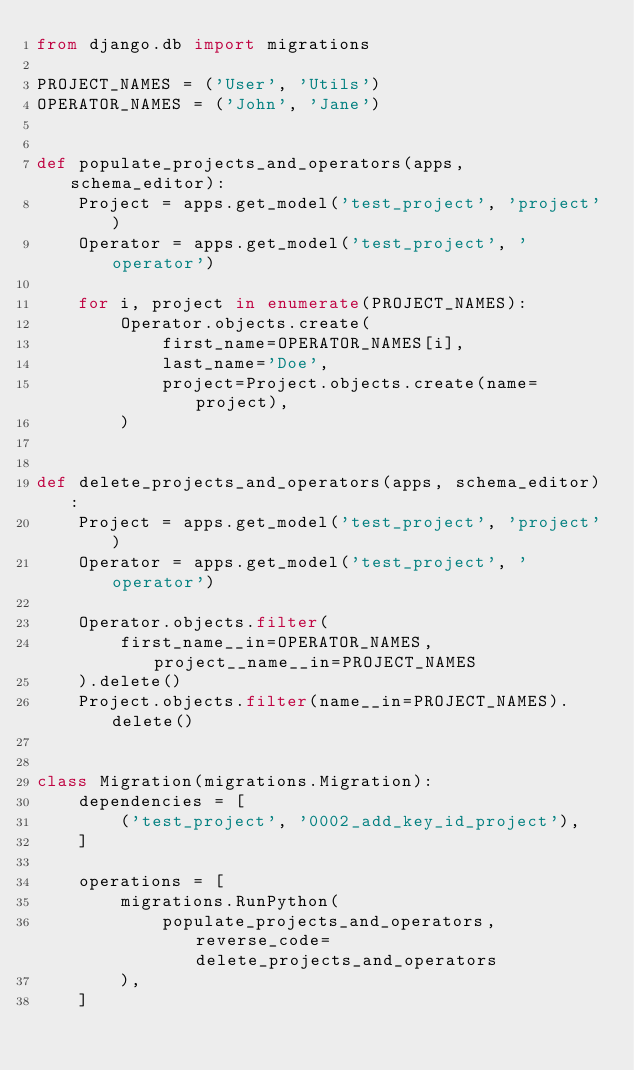Convert code to text. <code><loc_0><loc_0><loc_500><loc_500><_Python_>from django.db import migrations

PROJECT_NAMES = ('User', 'Utils')
OPERATOR_NAMES = ('John', 'Jane')


def populate_projects_and_operators(apps, schema_editor):
    Project = apps.get_model('test_project', 'project')
    Operator = apps.get_model('test_project', 'operator')

    for i, project in enumerate(PROJECT_NAMES):
        Operator.objects.create(
            first_name=OPERATOR_NAMES[i],
            last_name='Doe',
            project=Project.objects.create(name=project),
        )


def delete_projects_and_operators(apps, schema_editor):
    Project = apps.get_model('test_project', 'project')
    Operator = apps.get_model('test_project', 'operator')

    Operator.objects.filter(
        first_name__in=OPERATOR_NAMES, project__name__in=PROJECT_NAMES
    ).delete()
    Project.objects.filter(name__in=PROJECT_NAMES).delete()


class Migration(migrations.Migration):
    dependencies = [
        ('test_project', '0002_add_key_id_project'),
    ]

    operations = [
        migrations.RunPython(
            populate_projects_and_operators, reverse_code=delete_projects_and_operators
        ),
    ]
</code> 